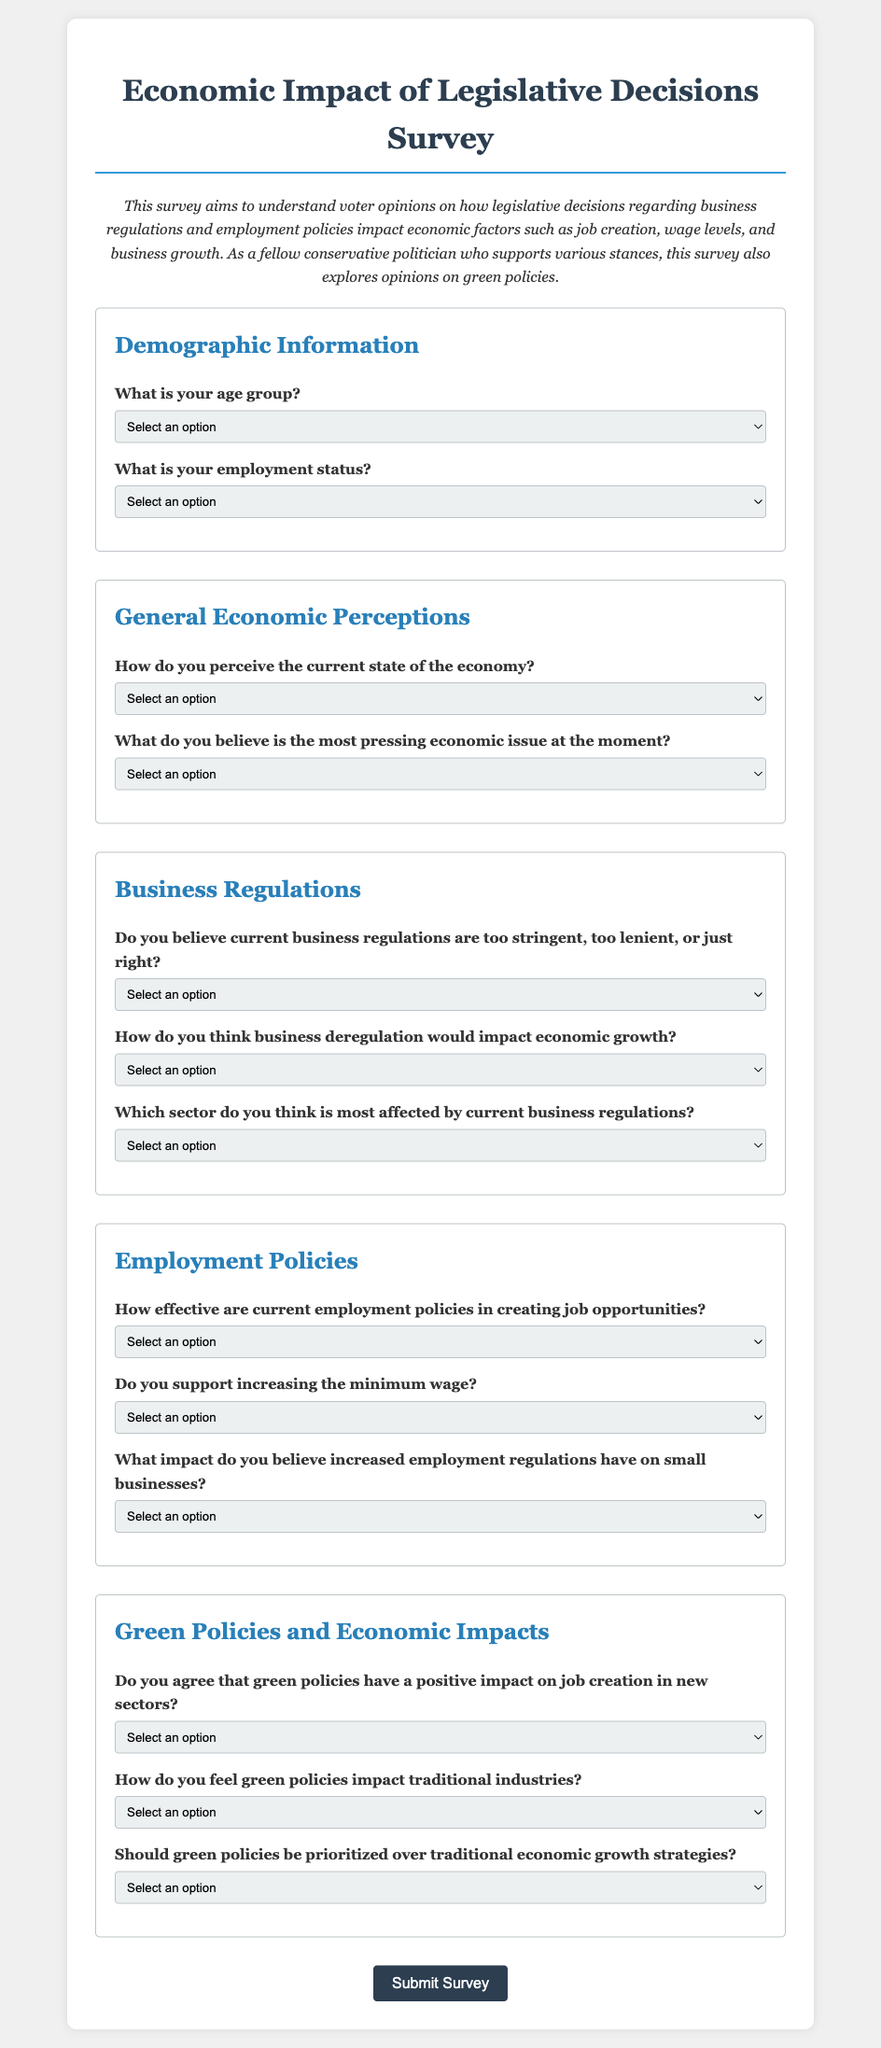What is the title of the survey? The title of the survey can be found at the top of the document, stating the purpose of the survey related to economic impacts.
Answer: Economic Impact of Legislative Decisions Survey How many main sections are there in the survey? The document outlines multiple sections, which can be counted from the headers present in the form.
Answer: Five What is one demographic question included in the survey? The document specifies demographic questions which can be directly quoted from the form.
Answer: What is your age group? What is the first question under General Economic Perceptions? The survey lists questions under various sections, including what's found under General Economic Perceptions, which can be identified clearly.
Answer: How do you perceive the current state of the economy? What does the survey ask about business regulations? The section on Business Regulations includes several questions, one of which can represent the general inquiry of the section.
Answer: Do you believe current business regulations are too stringent, too lenient, or just right? Which option is not included in the response for minimum wage support? The selection options for that question can be reviewed to determine which option is missing from the typical responses regarding wage policies.
Answer: None How is the feedback for green job creation solicited? The document outlines a question exploring opinions about the effect of green policies, which leads to a response selection.
Answer: Do you agree that green policies have a positive impact on job creation in new sectors? 